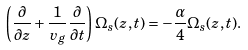<formula> <loc_0><loc_0><loc_500><loc_500>\left ( \frac { \partial } { \partial z } + \frac { 1 } { v _ { g } } \frac { \partial } { \partial t } \right ) \Omega _ { s } ( z , t ) = - \frac { \alpha } { 4 } \Omega _ { s } ( z , t ) .</formula> 